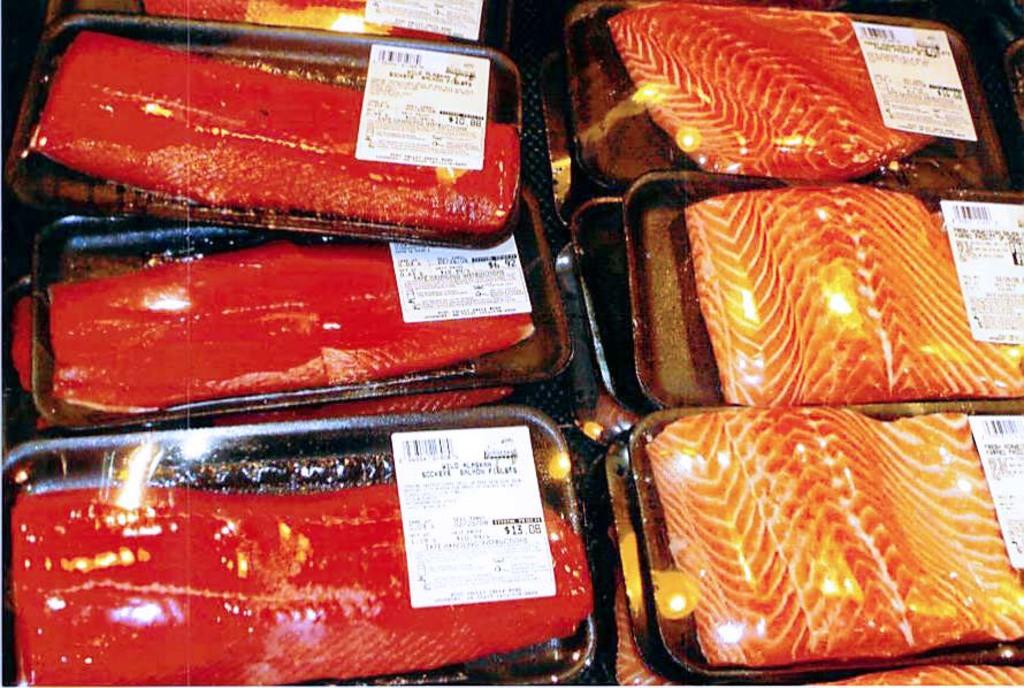What type of food is visible in the image? There are slices of fish in the image. Can you describe any additional details about the fish? The slices of fish have a price tag on them. What type of stamp can be seen on the fish in the image? There is no stamp visible on the fish in the image. Can you hear a whistle in the background of the image? There is no whistle present in the image, as it is a still image and does not contain any sound. 